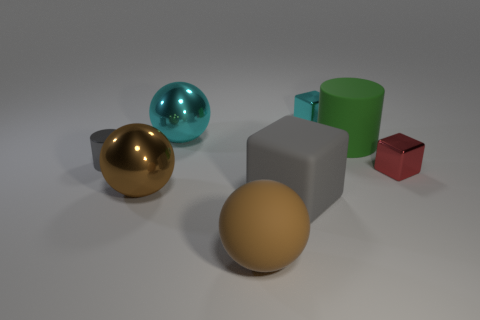Add 1 large cyan cylinders. How many objects exist? 9 Subtract all spheres. How many objects are left? 5 Add 2 tiny red matte objects. How many tiny red matte objects exist? 2 Subtract 1 red blocks. How many objects are left? 7 Subtract all large matte objects. Subtract all big gray rubber objects. How many objects are left? 4 Add 8 shiny blocks. How many shiny blocks are left? 10 